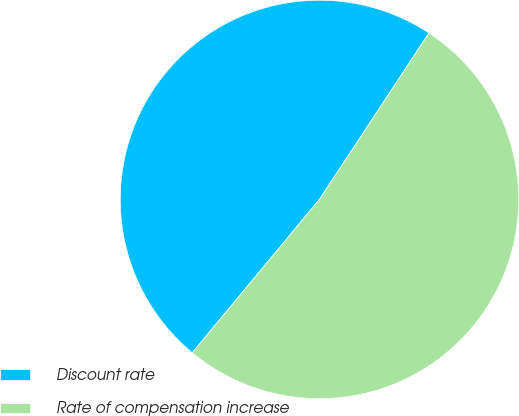<chart> <loc_0><loc_0><loc_500><loc_500><pie_chart><fcel>Discount rate<fcel>Rate of compensation increase<nl><fcel>48.24%<fcel>51.76%<nl></chart> 